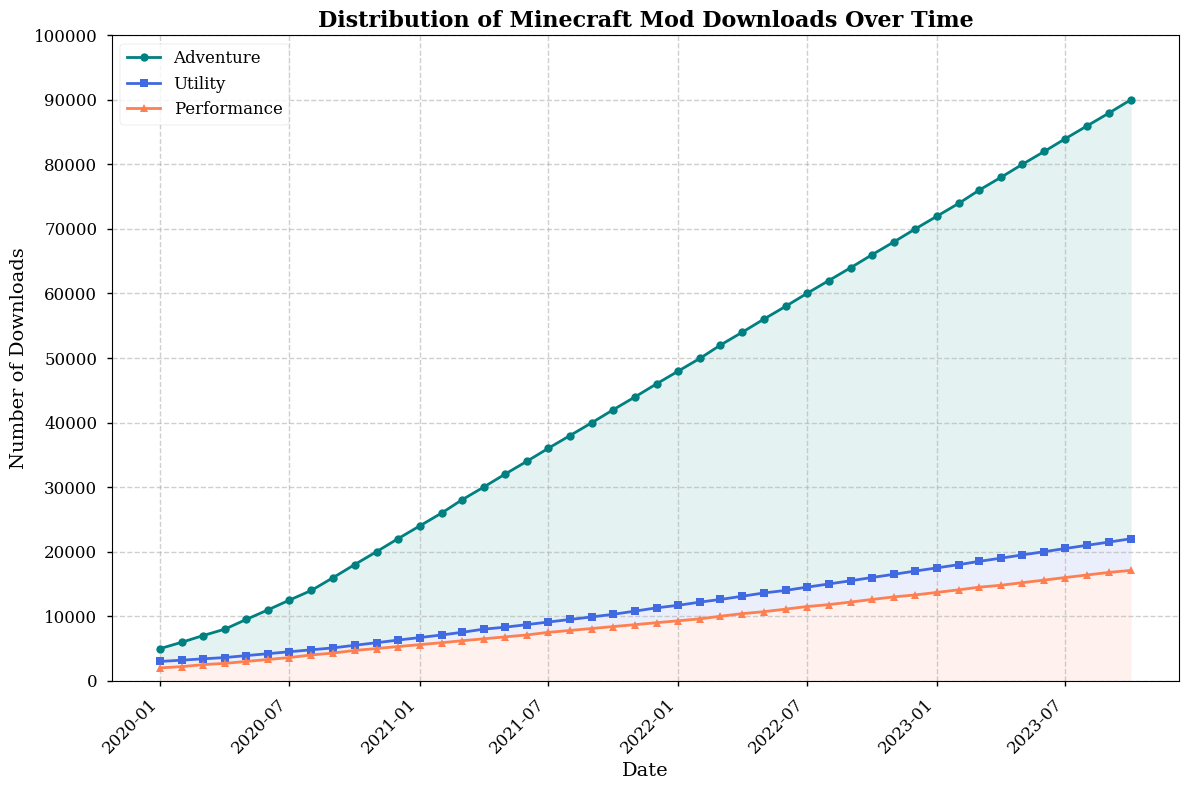Which mod category consistently had the highest number of downloads from 2020 to 2023? By examining the chart, note that the "Adventure" category consistently has the highest line throughout the time period.
Answer: Adventure What was the total number of downloads for the "Performance" category in July 2023? Locate July 2023 on the x-axis and find the corresponding value for the "Performance" line, which is 16000.
Answer: 16000 Based on the figure, which month had the most significant increase in downloads for the "Utility" category? Identify the two adjacent months with the largest difference in the "Utility" line height. The increase from January 2020 to February 2020 is the first large spike.
Answer: February 2020 How does the number of "Performance" downloads in January 2022 compare to the number of "Utility" downloads in the same month? Look at January 2022 on the x-axis for both categories. "Performance" has 9300 downloads, and "Utility" has 11700. Compare these values.
Answer: Utility had more downloads During which months does the "Adventure" category experience the fastest growth rate? Identify the section where the "Adventure" line has the steepest upward slope. The period from June 2020 to December 2020 shows the fastest upward movement.
Answer: June 2020 to December 2020 What is the difference in downloads between the "Adventure" and "Utility" categories in January 2023? Find January 2023 on the x-axis and get the values for "Adventure" and "Utility," which are 72000 and 17500, respectively. Subtract these values: 72000 - 17500 = 54500.
Answer: 54500 Which category had the smallest number of downloads at the beginning of the dataset? Look at the data points for January 2020. "Performance" has the smallest number of downloads with 2000 compared to "Adventure" (5000) and "Utility" (3000).
Answer: Performance How have the total downloads for each category changed from January 2020 to October 2023? Notice the initial and final values for each category. For "Adventure," it's 5000 to 90000; for "Utility," it's 3000 to 22000; for "Performance," it's 2000 to 17100. Each has shown an increase.
Answer: All have increased What is the visual trend for the "Utility" category during the year 2022? Inspect the line for the "Utility" category throughout 2022. The trend shows a steady increase in downloads.
Answer: Steady increase By how much did the "Performance" category downloads increase between the start and end of 2021? Find the values for January 2021 (5600) and December 2021 (9000). Subtract them to find the increase: 9000 - 5600 = 3400.
Answer: 3400 